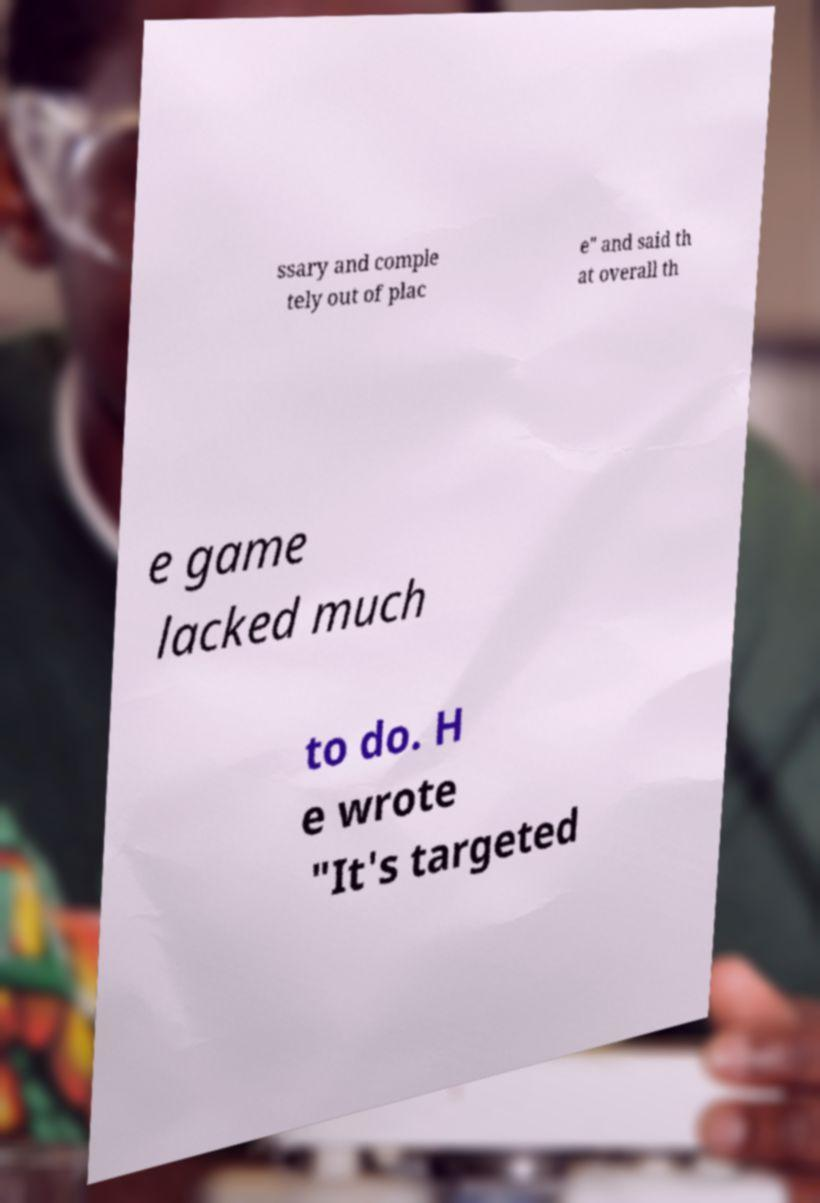Could you assist in decoding the text presented in this image and type it out clearly? ssary and comple tely out of plac e" and said th at overall th e game lacked much to do. H e wrote "It's targeted 